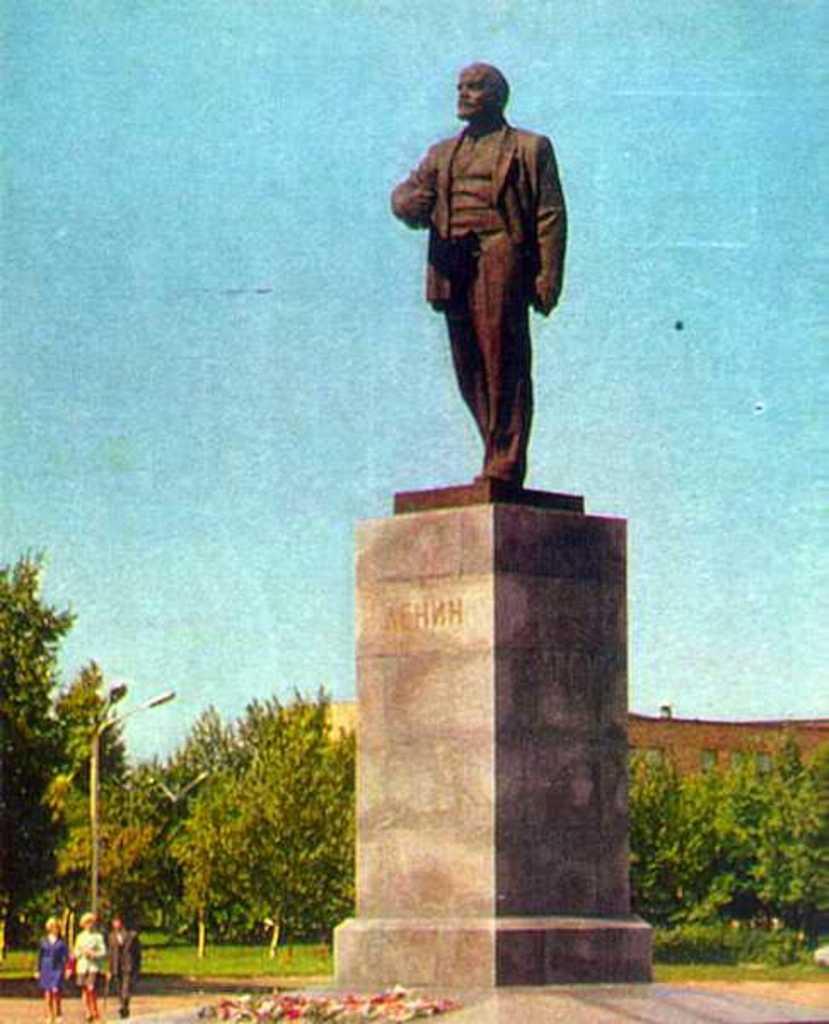In one or two sentences, can you explain what this image depicts? In this picture there are people walking and we can see sculpture on the platform, grass, lights, pole and trees. In the background of the image we can see wall, windows and sky. 